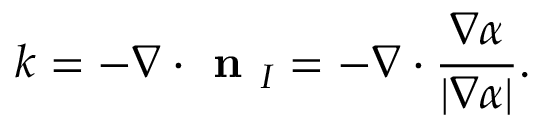<formula> <loc_0><loc_0><loc_500><loc_500>k = - \nabla \cdot n _ { I } = - \nabla \cdot \frac { \nabla \alpha } { | \nabla \alpha | } .</formula> 